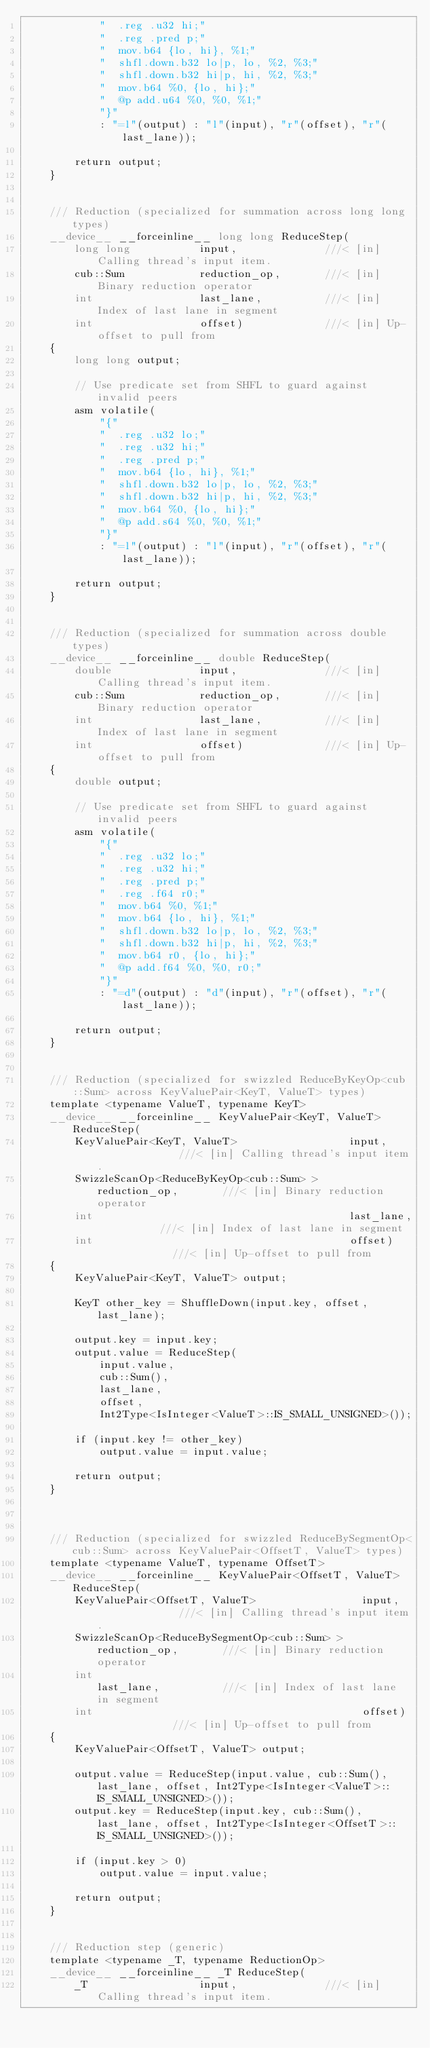<code> <loc_0><loc_0><loc_500><loc_500><_Cuda_>            "  .reg .u32 hi;"
            "  .reg .pred p;"
            "  mov.b64 {lo, hi}, %1;"
            "  shfl.down.b32 lo|p, lo, %2, %3;"
            "  shfl.down.b32 hi|p, hi, %2, %3;"
            "  mov.b64 %0, {lo, hi};"
            "  @p add.u64 %0, %0, %1;"
            "}"
            : "=l"(output) : "l"(input), "r"(offset), "r"(last_lane));

        return output;
    }


    /// Reduction (specialized for summation across long long types)
    __device__ __forceinline__ long long ReduceStep(
        long long           input,              ///< [in] Calling thread's input item.
        cub::Sum            reduction_op,       ///< [in] Binary reduction operator
        int                 last_lane,          ///< [in] Index of last lane in segment
        int                 offset)             ///< [in] Up-offset to pull from
    {
        long long output;

        // Use predicate set from SHFL to guard against invalid peers
        asm volatile(
            "{"
            "  .reg .u32 lo;"
            "  .reg .u32 hi;"
            "  .reg .pred p;"
            "  mov.b64 {lo, hi}, %1;"
            "  shfl.down.b32 lo|p, lo, %2, %3;"
            "  shfl.down.b32 hi|p, hi, %2, %3;"
            "  mov.b64 %0, {lo, hi};"
            "  @p add.s64 %0, %0, %1;"
            "}"
            : "=l"(output) : "l"(input), "r"(offset), "r"(last_lane));

        return output;
    }


    /// Reduction (specialized for summation across double types)
    __device__ __forceinline__ double ReduceStep(
        double              input,              ///< [in] Calling thread's input item.
        cub::Sum            reduction_op,       ///< [in] Binary reduction operator
        int                 last_lane,          ///< [in] Index of last lane in segment
        int                 offset)             ///< [in] Up-offset to pull from
    {
        double output;

        // Use predicate set from SHFL to guard against invalid peers
        asm volatile(
            "{"
            "  .reg .u32 lo;"
            "  .reg .u32 hi;"
            "  .reg .pred p;"
            "  .reg .f64 r0;"
            "  mov.b64 %0, %1;"
            "  mov.b64 {lo, hi}, %1;"
            "  shfl.down.b32 lo|p, lo, %2, %3;"
            "  shfl.down.b32 hi|p, hi, %2, %3;"
            "  mov.b64 r0, {lo, hi};"
            "  @p add.f64 %0, %0, r0;"
            "}"
            : "=d"(output) : "d"(input), "r"(offset), "r"(last_lane));

        return output;
    }


    /// Reduction (specialized for swizzled ReduceByKeyOp<cub::Sum> across KeyValuePair<KeyT, ValueT> types)
    template <typename ValueT, typename KeyT>
    __device__ __forceinline__ KeyValuePair<KeyT, ValueT> ReduceStep(
        KeyValuePair<KeyT, ValueT>                  input,              ///< [in] Calling thread's input item.
        SwizzleScanOp<ReduceByKeyOp<cub::Sum> >     reduction_op,       ///< [in] Binary reduction operator
        int                                         last_lane,          ///< [in] Index of last lane in segment
        int                                         offset)             ///< [in] Up-offset to pull from
    {
        KeyValuePair<KeyT, ValueT> output;

        KeyT other_key = ShuffleDown(input.key, offset, last_lane);
        
        output.key = input.key;
        output.value = ReduceStep(
            input.value, 
            cub::Sum(), 
            last_lane, 
            offset, 
            Int2Type<IsInteger<ValueT>::IS_SMALL_UNSIGNED>());

        if (input.key != other_key)
            output.value = input.value;

        return output;
    }



    /// Reduction (specialized for swizzled ReduceBySegmentOp<cub::Sum> across KeyValuePair<OffsetT, ValueT> types)
    template <typename ValueT, typename OffsetT>
    __device__ __forceinline__ KeyValuePair<OffsetT, ValueT> ReduceStep(
        KeyValuePair<OffsetT, ValueT>                 input,              ///< [in] Calling thread's input item.
        SwizzleScanOp<ReduceBySegmentOp<cub::Sum> >   reduction_op,       ///< [in] Binary reduction operator
        int                                           last_lane,          ///< [in] Index of last lane in segment
        int                                           offset)             ///< [in] Up-offset to pull from
    {
        KeyValuePair<OffsetT, ValueT> output;

        output.value = ReduceStep(input.value, cub::Sum(), last_lane, offset, Int2Type<IsInteger<ValueT>::IS_SMALL_UNSIGNED>());
        output.key = ReduceStep(input.key, cub::Sum(), last_lane, offset, Int2Type<IsInteger<OffsetT>::IS_SMALL_UNSIGNED>());

        if (input.key > 0)
            output.value = input.value;

        return output;
    }


    /// Reduction step (generic)
    template <typename _T, typename ReductionOp>
    __device__ __forceinline__ _T ReduceStep(
        _T                  input,              ///< [in] Calling thread's input item.</code> 